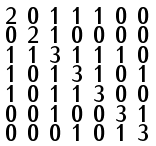<formula> <loc_0><loc_0><loc_500><loc_500>\begin{smallmatrix} 2 & 0 & 1 & 1 & 1 & 0 & 0 \\ 0 & 2 & 1 & 0 & 0 & 0 & 0 \\ 1 & 1 & 3 & 1 & 1 & 1 & 0 \\ 1 & 0 & 1 & 3 & 1 & 0 & 1 \\ 1 & 0 & 1 & 1 & 3 & 0 & 0 \\ 0 & 0 & 1 & 0 & 0 & 3 & 1 \\ 0 & 0 & 0 & 1 & 0 & 1 & 3 \end{smallmatrix}</formula> 